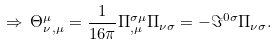<formula> <loc_0><loc_0><loc_500><loc_500>\Rightarrow \, { \Theta ^ { \mu } _ { \nu } } _ { , \mu } = { \frac { 1 } { 1 6 \pi } } { \Pi ^ { \sigma \mu } _ { , \mu } \Pi _ { \nu \sigma } } = { - \Im ^ { 0 \sigma } } \Pi _ { \nu \sigma } .</formula> 